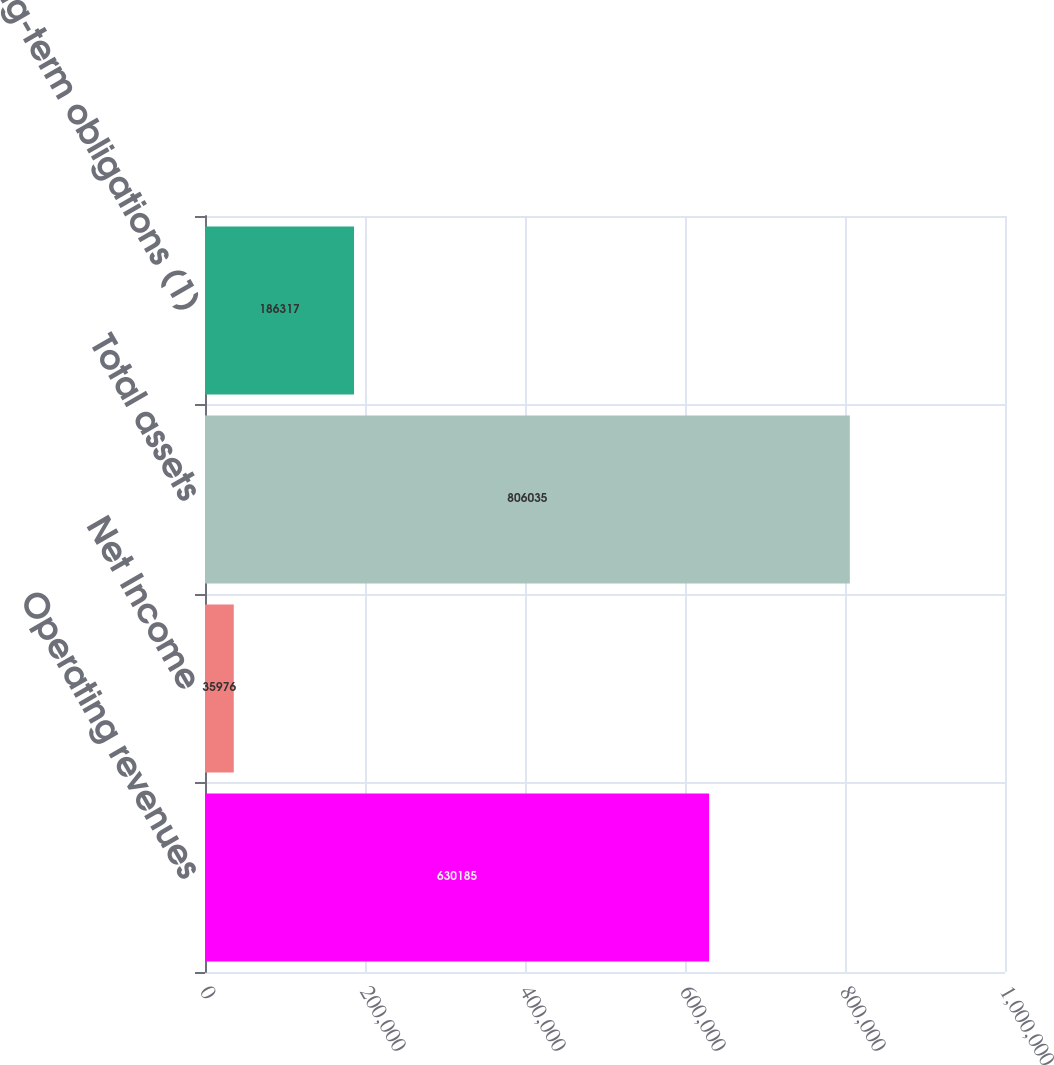Convert chart. <chart><loc_0><loc_0><loc_500><loc_500><bar_chart><fcel>Operating revenues<fcel>Net Income<fcel>Total assets<fcel>Long-term obligations (1)<nl><fcel>630185<fcel>35976<fcel>806035<fcel>186317<nl></chart> 